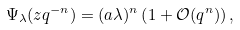Convert formula to latex. <formula><loc_0><loc_0><loc_500><loc_500>\Psi _ { \lambda } ( z q ^ { - n } ) = ( a \lambda ) ^ { n } \left ( 1 + \mathcal { O } ( q ^ { n } ) \right ) ,</formula> 